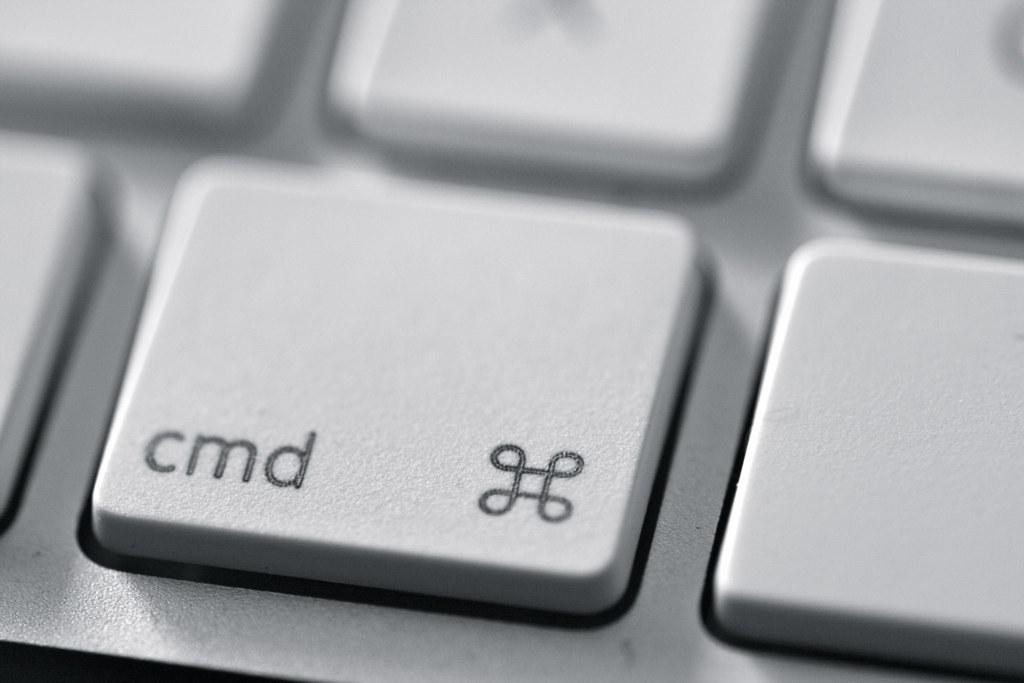<image>
Render a clear and concise summary of the photo. a mac keyboard with the cmd key in focus 